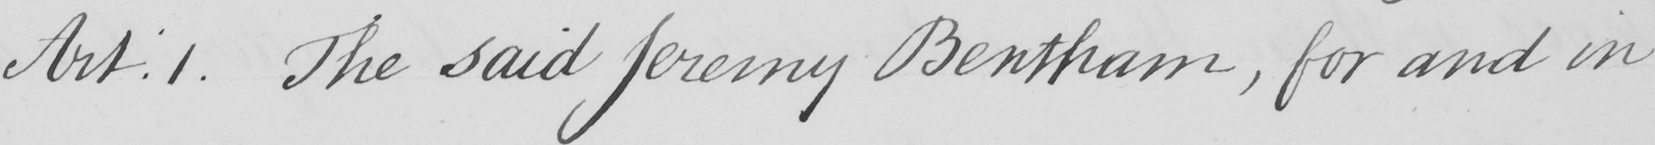Please provide the text content of this handwritten line. Art.1 . The said Jeremy Bentham , for and in 